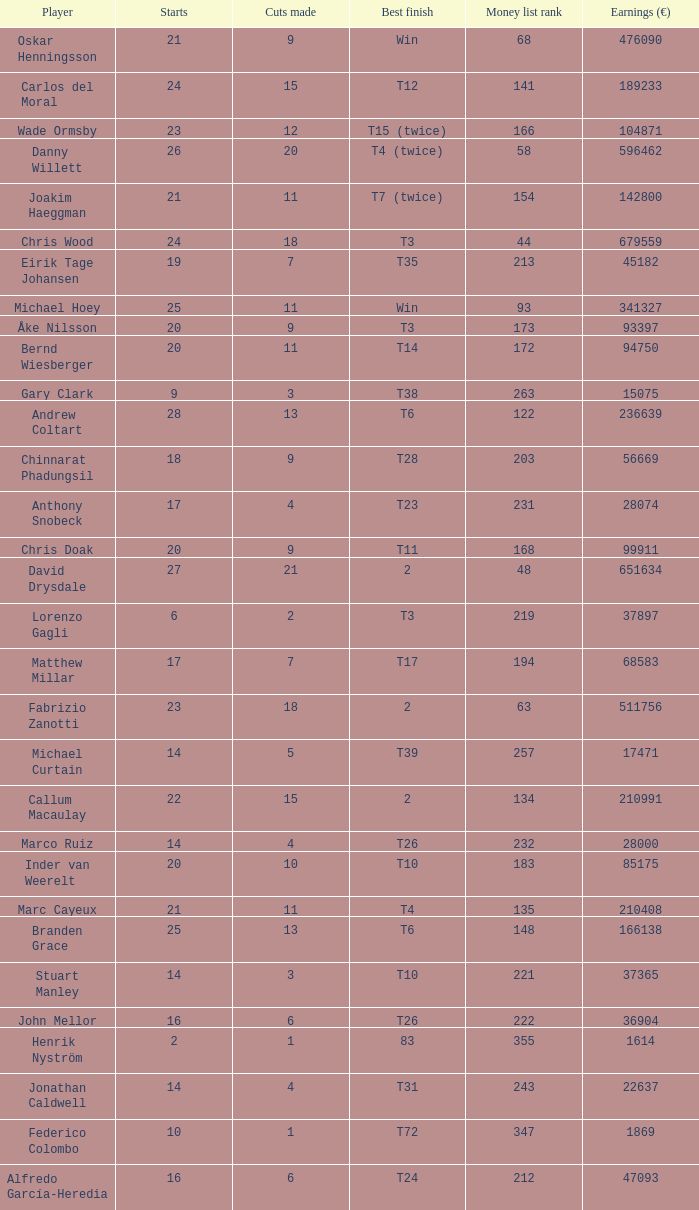How many cuts did Bernd Wiesberger make? 11.0. 